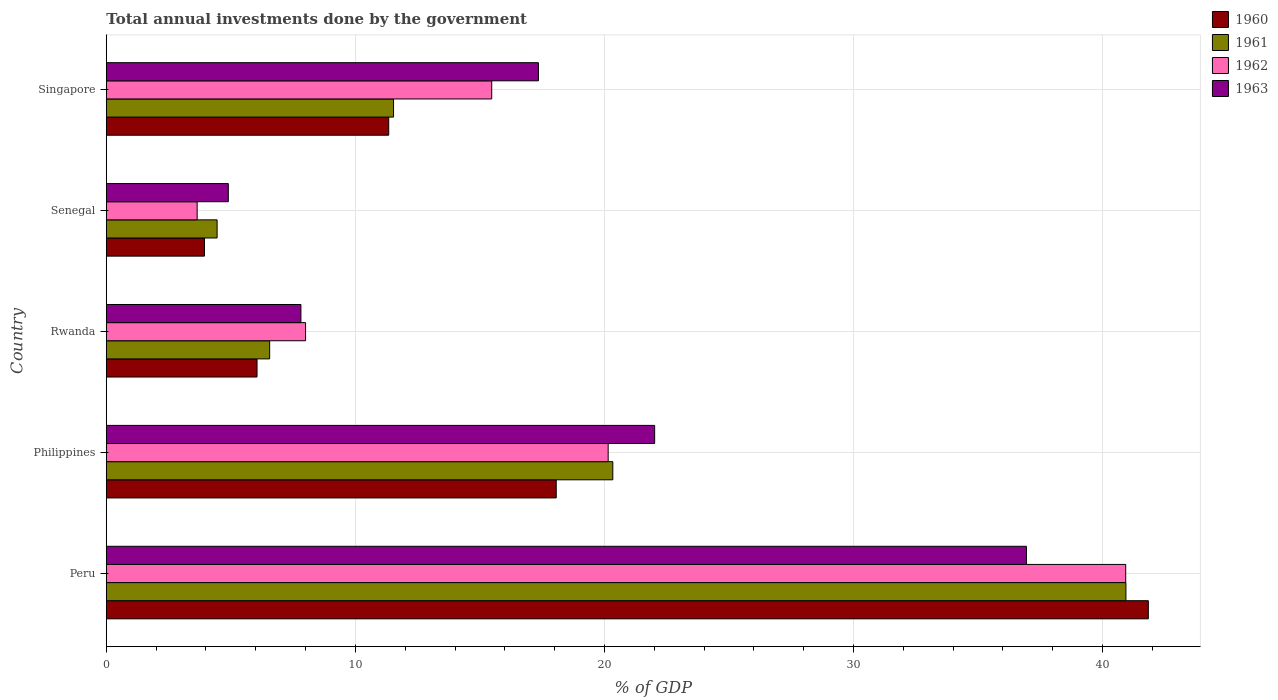How many groups of bars are there?
Your answer should be very brief. 5. Are the number of bars per tick equal to the number of legend labels?
Ensure brevity in your answer.  Yes. How many bars are there on the 1st tick from the bottom?
Keep it short and to the point. 4. What is the label of the 3rd group of bars from the top?
Provide a short and direct response. Rwanda. What is the total annual investments done by the government in 1963 in Rwanda?
Make the answer very short. 7.81. Across all countries, what is the maximum total annual investments done by the government in 1963?
Ensure brevity in your answer.  36.94. Across all countries, what is the minimum total annual investments done by the government in 1961?
Make the answer very short. 4.45. In which country was the total annual investments done by the government in 1960 maximum?
Offer a very short reply. Peru. In which country was the total annual investments done by the government in 1961 minimum?
Ensure brevity in your answer.  Senegal. What is the total total annual investments done by the government in 1962 in the graph?
Make the answer very short. 88.2. What is the difference between the total annual investments done by the government in 1961 in Senegal and that in Singapore?
Offer a very short reply. -7.08. What is the difference between the total annual investments done by the government in 1963 in Rwanda and the total annual investments done by the government in 1962 in Senegal?
Make the answer very short. 4.17. What is the average total annual investments done by the government in 1961 per country?
Make the answer very short. 16.76. What is the difference between the total annual investments done by the government in 1961 and total annual investments done by the government in 1960 in Philippines?
Offer a very short reply. 2.27. What is the ratio of the total annual investments done by the government in 1961 in Peru to that in Senegal?
Your response must be concise. 9.2. Is the total annual investments done by the government in 1961 in Peru less than that in Rwanda?
Offer a very short reply. No. Is the difference between the total annual investments done by the government in 1961 in Peru and Rwanda greater than the difference between the total annual investments done by the government in 1960 in Peru and Rwanda?
Give a very brief answer. No. What is the difference between the highest and the second highest total annual investments done by the government in 1962?
Offer a terse response. 20.78. What is the difference between the highest and the lowest total annual investments done by the government in 1960?
Give a very brief answer. 37.9. Is the sum of the total annual investments done by the government in 1960 in Rwanda and Senegal greater than the maximum total annual investments done by the government in 1962 across all countries?
Your answer should be very brief. No. Is it the case that in every country, the sum of the total annual investments done by the government in 1963 and total annual investments done by the government in 1961 is greater than the sum of total annual investments done by the government in 1962 and total annual investments done by the government in 1960?
Make the answer very short. No. What does the 3rd bar from the top in Philippines represents?
Your answer should be very brief. 1961. Is it the case that in every country, the sum of the total annual investments done by the government in 1962 and total annual investments done by the government in 1961 is greater than the total annual investments done by the government in 1960?
Provide a short and direct response. Yes. How many bars are there?
Provide a succinct answer. 20. What is the difference between two consecutive major ticks on the X-axis?
Offer a very short reply. 10. Does the graph contain any zero values?
Offer a very short reply. No. Does the graph contain grids?
Your answer should be very brief. Yes. How many legend labels are there?
Provide a short and direct response. 4. What is the title of the graph?
Offer a very short reply. Total annual investments done by the government. What is the label or title of the X-axis?
Provide a short and direct response. % of GDP. What is the label or title of the Y-axis?
Your response must be concise. Country. What is the % of GDP of 1960 in Peru?
Offer a terse response. 41.84. What is the % of GDP of 1961 in Peru?
Provide a short and direct response. 40.94. What is the % of GDP in 1962 in Peru?
Make the answer very short. 40.93. What is the % of GDP in 1963 in Peru?
Offer a terse response. 36.94. What is the % of GDP of 1960 in Philippines?
Provide a short and direct response. 18.06. What is the % of GDP of 1961 in Philippines?
Provide a short and direct response. 20.34. What is the % of GDP of 1962 in Philippines?
Ensure brevity in your answer.  20.15. What is the % of GDP in 1963 in Philippines?
Make the answer very short. 22.02. What is the % of GDP in 1960 in Rwanda?
Provide a short and direct response. 6.05. What is the % of GDP in 1961 in Rwanda?
Your answer should be very brief. 6.56. What is the % of GDP of 1962 in Rwanda?
Ensure brevity in your answer.  8. What is the % of GDP of 1963 in Rwanda?
Your response must be concise. 7.81. What is the % of GDP of 1960 in Senegal?
Keep it short and to the point. 3.94. What is the % of GDP in 1961 in Senegal?
Your answer should be very brief. 4.45. What is the % of GDP in 1962 in Senegal?
Make the answer very short. 3.65. What is the % of GDP in 1963 in Senegal?
Make the answer very short. 4.9. What is the % of GDP in 1960 in Singapore?
Make the answer very short. 11.34. What is the % of GDP of 1961 in Singapore?
Keep it short and to the point. 11.53. What is the % of GDP in 1962 in Singapore?
Your answer should be very brief. 15.47. What is the % of GDP in 1963 in Singapore?
Provide a succinct answer. 17.35. Across all countries, what is the maximum % of GDP in 1960?
Provide a short and direct response. 41.84. Across all countries, what is the maximum % of GDP of 1961?
Make the answer very short. 40.94. Across all countries, what is the maximum % of GDP in 1962?
Make the answer very short. 40.93. Across all countries, what is the maximum % of GDP in 1963?
Make the answer very short. 36.94. Across all countries, what is the minimum % of GDP in 1960?
Provide a short and direct response. 3.94. Across all countries, what is the minimum % of GDP of 1961?
Your answer should be very brief. 4.45. Across all countries, what is the minimum % of GDP of 1962?
Offer a terse response. 3.65. Across all countries, what is the minimum % of GDP of 1963?
Keep it short and to the point. 4.9. What is the total % of GDP in 1960 in the graph?
Offer a very short reply. 81.23. What is the total % of GDP of 1961 in the graph?
Keep it short and to the point. 83.81. What is the total % of GDP of 1962 in the graph?
Your response must be concise. 88.2. What is the total % of GDP of 1963 in the graph?
Provide a succinct answer. 89.02. What is the difference between the % of GDP in 1960 in Peru and that in Philippines?
Your answer should be compact. 23.77. What is the difference between the % of GDP of 1961 in Peru and that in Philippines?
Make the answer very short. 20.6. What is the difference between the % of GDP of 1962 in Peru and that in Philippines?
Offer a terse response. 20.78. What is the difference between the % of GDP of 1963 in Peru and that in Philippines?
Provide a succinct answer. 14.93. What is the difference between the % of GDP of 1960 in Peru and that in Rwanda?
Provide a short and direct response. 35.79. What is the difference between the % of GDP in 1961 in Peru and that in Rwanda?
Offer a very short reply. 34.38. What is the difference between the % of GDP of 1962 in Peru and that in Rwanda?
Make the answer very short. 32.93. What is the difference between the % of GDP of 1963 in Peru and that in Rwanda?
Keep it short and to the point. 29.13. What is the difference between the % of GDP in 1960 in Peru and that in Senegal?
Your answer should be very brief. 37.9. What is the difference between the % of GDP of 1961 in Peru and that in Senegal?
Offer a terse response. 36.49. What is the difference between the % of GDP of 1962 in Peru and that in Senegal?
Offer a terse response. 37.28. What is the difference between the % of GDP of 1963 in Peru and that in Senegal?
Give a very brief answer. 32.04. What is the difference between the % of GDP in 1960 in Peru and that in Singapore?
Offer a very short reply. 30.5. What is the difference between the % of GDP in 1961 in Peru and that in Singapore?
Make the answer very short. 29.41. What is the difference between the % of GDP of 1962 in Peru and that in Singapore?
Your response must be concise. 25.45. What is the difference between the % of GDP of 1963 in Peru and that in Singapore?
Offer a very short reply. 19.59. What is the difference between the % of GDP of 1960 in Philippines and that in Rwanda?
Offer a terse response. 12.01. What is the difference between the % of GDP of 1961 in Philippines and that in Rwanda?
Ensure brevity in your answer.  13.78. What is the difference between the % of GDP in 1962 in Philippines and that in Rwanda?
Your answer should be very brief. 12.15. What is the difference between the % of GDP in 1963 in Philippines and that in Rwanda?
Your answer should be compact. 14.2. What is the difference between the % of GDP of 1960 in Philippines and that in Senegal?
Ensure brevity in your answer.  14.12. What is the difference between the % of GDP of 1961 in Philippines and that in Senegal?
Your answer should be compact. 15.89. What is the difference between the % of GDP of 1962 in Philippines and that in Senegal?
Provide a succinct answer. 16.5. What is the difference between the % of GDP of 1963 in Philippines and that in Senegal?
Ensure brevity in your answer.  17.12. What is the difference between the % of GDP in 1960 in Philippines and that in Singapore?
Provide a succinct answer. 6.73. What is the difference between the % of GDP in 1961 in Philippines and that in Singapore?
Your answer should be compact. 8.8. What is the difference between the % of GDP in 1962 in Philippines and that in Singapore?
Your answer should be very brief. 4.68. What is the difference between the % of GDP of 1963 in Philippines and that in Singapore?
Provide a succinct answer. 4.67. What is the difference between the % of GDP in 1960 in Rwanda and that in Senegal?
Provide a succinct answer. 2.11. What is the difference between the % of GDP of 1961 in Rwanda and that in Senegal?
Provide a short and direct response. 2.11. What is the difference between the % of GDP of 1962 in Rwanda and that in Senegal?
Provide a succinct answer. 4.35. What is the difference between the % of GDP of 1963 in Rwanda and that in Senegal?
Give a very brief answer. 2.91. What is the difference between the % of GDP in 1960 in Rwanda and that in Singapore?
Provide a succinct answer. -5.29. What is the difference between the % of GDP of 1961 in Rwanda and that in Singapore?
Offer a very short reply. -4.97. What is the difference between the % of GDP of 1962 in Rwanda and that in Singapore?
Your answer should be compact. -7.47. What is the difference between the % of GDP of 1963 in Rwanda and that in Singapore?
Provide a short and direct response. -9.54. What is the difference between the % of GDP of 1960 in Senegal and that in Singapore?
Give a very brief answer. -7.4. What is the difference between the % of GDP of 1961 in Senegal and that in Singapore?
Ensure brevity in your answer.  -7.08. What is the difference between the % of GDP of 1962 in Senegal and that in Singapore?
Provide a short and direct response. -11.83. What is the difference between the % of GDP of 1963 in Senegal and that in Singapore?
Provide a succinct answer. -12.45. What is the difference between the % of GDP of 1960 in Peru and the % of GDP of 1961 in Philippines?
Offer a terse response. 21.5. What is the difference between the % of GDP of 1960 in Peru and the % of GDP of 1962 in Philippines?
Give a very brief answer. 21.69. What is the difference between the % of GDP of 1960 in Peru and the % of GDP of 1963 in Philippines?
Offer a very short reply. 19.82. What is the difference between the % of GDP of 1961 in Peru and the % of GDP of 1962 in Philippines?
Make the answer very short. 20.79. What is the difference between the % of GDP of 1961 in Peru and the % of GDP of 1963 in Philippines?
Offer a very short reply. 18.92. What is the difference between the % of GDP in 1962 in Peru and the % of GDP in 1963 in Philippines?
Provide a short and direct response. 18.91. What is the difference between the % of GDP in 1960 in Peru and the % of GDP in 1961 in Rwanda?
Provide a short and direct response. 35.28. What is the difference between the % of GDP of 1960 in Peru and the % of GDP of 1962 in Rwanda?
Provide a succinct answer. 33.84. What is the difference between the % of GDP of 1960 in Peru and the % of GDP of 1963 in Rwanda?
Offer a terse response. 34.02. What is the difference between the % of GDP of 1961 in Peru and the % of GDP of 1962 in Rwanda?
Give a very brief answer. 32.94. What is the difference between the % of GDP in 1961 in Peru and the % of GDP in 1963 in Rwanda?
Provide a succinct answer. 33.12. What is the difference between the % of GDP of 1962 in Peru and the % of GDP of 1963 in Rwanda?
Provide a short and direct response. 33.12. What is the difference between the % of GDP in 1960 in Peru and the % of GDP in 1961 in Senegal?
Provide a succinct answer. 37.39. What is the difference between the % of GDP in 1960 in Peru and the % of GDP in 1962 in Senegal?
Offer a very short reply. 38.19. What is the difference between the % of GDP in 1960 in Peru and the % of GDP in 1963 in Senegal?
Make the answer very short. 36.94. What is the difference between the % of GDP of 1961 in Peru and the % of GDP of 1962 in Senegal?
Provide a succinct answer. 37.29. What is the difference between the % of GDP in 1961 in Peru and the % of GDP in 1963 in Senegal?
Give a very brief answer. 36.04. What is the difference between the % of GDP in 1962 in Peru and the % of GDP in 1963 in Senegal?
Provide a short and direct response. 36.03. What is the difference between the % of GDP in 1960 in Peru and the % of GDP in 1961 in Singapore?
Provide a short and direct response. 30.3. What is the difference between the % of GDP in 1960 in Peru and the % of GDP in 1962 in Singapore?
Offer a very short reply. 26.36. What is the difference between the % of GDP in 1960 in Peru and the % of GDP in 1963 in Singapore?
Provide a succinct answer. 24.49. What is the difference between the % of GDP in 1961 in Peru and the % of GDP in 1962 in Singapore?
Provide a succinct answer. 25.46. What is the difference between the % of GDP of 1961 in Peru and the % of GDP of 1963 in Singapore?
Your answer should be very brief. 23.59. What is the difference between the % of GDP of 1962 in Peru and the % of GDP of 1963 in Singapore?
Offer a very short reply. 23.58. What is the difference between the % of GDP in 1960 in Philippines and the % of GDP in 1961 in Rwanda?
Your answer should be compact. 11.51. What is the difference between the % of GDP of 1960 in Philippines and the % of GDP of 1962 in Rwanda?
Your answer should be very brief. 10.06. What is the difference between the % of GDP of 1960 in Philippines and the % of GDP of 1963 in Rwanda?
Make the answer very short. 10.25. What is the difference between the % of GDP of 1961 in Philippines and the % of GDP of 1962 in Rwanda?
Provide a succinct answer. 12.34. What is the difference between the % of GDP of 1961 in Philippines and the % of GDP of 1963 in Rwanda?
Your answer should be compact. 12.52. What is the difference between the % of GDP in 1962 in Philippines and the % of GDP in 1963 in Rwanda?
Make the answer very short. 12.34. What is the difference between the % of GDP in 1960 in Philippines and the % of GDP in 1961 in Senegal?
Offer a very short reply. 13.62. What is the difference between the % of GDP of 1960 in Philippines and the % of GDP of 1962 in Senegal?
Offer a terse response. 14.42. What is the difference between the % of GDP in 1960 in Philippines and the % of GDP in 1963 in Senegal?
Ensure brevity in your answer.  13.17. What is the difference between the % of GDP of 1961 in Philippines and the % of GDP of 1962 in Senegal?
Your answer should be compact. 16.69. What is the difference between the % of GDP of 1961 in Philippines and the % of GDP of 1963 in Senegal?
Give a very brief answer. 15.44. What is the difference between the % of GDP in 1962 in Philippines and the % of GDP in 1963 in Senegal?
Your response must be concise. 15.25. What is the difference between the % of GDP in 1960 in Philippines and the % of GDP in 1961 in Singapore?
Keep it short and to the point. 6.53. What is the difference between the % of GDP of 1960 in Philippines and the % of GDP of 1962 in Singapore?
Offer a very short reply. 2.59. What is the difference between the % of GDP in 1960 in Philippines and the % of GDP in 1963 in Singapore?
Offer a terse response. 0.72. What is the difference between the % of GDP of 1961 in Philippines and the % of GDP of 1962 in Singapore?
Your answer should be compact. 4.86. What is the difference between the % of GDP of 1961 in Philippines and the % of GDP of 1963 in Singapore?
Your response must be concise. 2.99. What is the difference between the % of GDP of 1962 in Philippines and the % of GDP of 1963 in Singapore?
Give a very brief answer. 2.8. What is the difference between the % of GDP in 1960 in Rwanda and the % of GDP in 1961 in Senegal?
Your answer should be compact. 1.6. What is the difference between the % of GDP in 1960 in Rwanda and the % of GDP in 1962 in Senegal?
Offer a terse response. 2.4. What is the difference between the % of GDP of 1960 in Rwanda and the % of GDP of 1963 in Senegal?
Make the answer very short. 1.15. What is the difference between the % of GDP in 1961 in Rwanda and the % of GDP in 1962 in Senegal?
Provide a succinct answer. 2.91. What is the difference between the % of GDP of 1961 in Rwanda and the % of GDP of 1963 in Senegal?
Provide a short and direct response. 1.66. What is the difference between the % of GDP of 1962 in Rwanda and the % of GDP of 1963 in Senegal?
Offer a very short reply. 3.1. What is the difference between the % of GDP in 1960 in Rwanda and the % of GDP in 1961 in Singapore?
Offer a very short reply. -5.48. What is the difference between the % of GDP of 1960 in Rwanda and the % of GDP of 1962 in Singapore?
Provide a succinct answer. -9.42. What is the difference between the % of GDP in 1960 in Rwanda and the % of GDP in 1963 in Singapore?
Make the answer very short. -11.3. What is the difference between the % of GDP of 1961 in Rwanda and the % of GDP of 1962 in Singapore?
Provide a short and direct response. -8.92. What is the difference between the % of GDP of 1961 in Rwanda and the % of GDP of 1963 in Singapore?
Offer a very short reply. -10.79. What is the difference between the % of GDP in 1962 in Rwanda and the % of GDP in 1963 in Singapore?
Ensure brevity in your answer.  -9.35. What is the difference between the % of GDP of 1960 in Senegal and the % of GDP of 1961 in Singapore?
Offer a very short reply. -7.59. What is the difference between the % of GDP of 1960 in Senegal and the % of GDP of 1962 in Singapore?
Provide a short and direct response. -11.53. What is the difference between the % of GDP of 1960 in Senegal and the % of GDP of 1963 in Singapore?
Offer a terse response. -13.41. What is the difference between the % of GDP in 1961 in Senegal and the % of GDP in 1962 in Singapore?
Provide a short and direct response. -11.03. What is the difference between the % of GDP in 1961 in Senegal and the % of GDP in 1963 in Singapore?
Provide a succinct answer. -12.9. What is the difference between the % of GDP of 1962 in Senegal and the % of GDP of 1963 in Singapore?
Your answer should be very brief. -13.7. What is the average % of GDP of 1960 per country?
Keep it short and to the point. 16.25. What is the average % of GDP of 1961 per country?
Ensure brevity in your answer.  16.76. What is the average % of GDP of 1962 per country?
Ensure brevity in your answer.  17.64. What is the average % of GDP of 1963 per country?
Keep it short and to the point. 17.8. What is the difference between the % of GDP in 1960 and % of GDP in 1961 in Peru?
Your answer should be very brief. 0.9. What is the difference between the % of GDP in 1960 and % of GDP in 1962 in Peru?
Your answer should be very brief. 0.91. What is the difference between the % of GDP in 1960 and % of GDP in 1963 in Peru?
Your answer should be very brief. 4.89. What is the difference between the % of GDP of 1961 and % of GDP of 1962 in Peru?
Provide a short and direct response. 0.01. What is the difference between the % of GDP of 1961 and % of GDP of 1963 in Peru?
Offer a very short reply. 3.99. What is the difference between the % of GDP of 1962 and % of GDP of 1963 in Peru?
Your answer should be compact. 3.99. What is the difference between the % of GDP of 1960 and % of GDP of 1961 in Philippines?
Offer a terse response. -2.27. What is the difference between the % of GDP of 1960 and % of GDP of 1962 in Philippines?
Make the answer very short. -2.09. What is the difference between the % of GDP of 1960 and % of GDP of 1963 in Philippines?
Make the answer very short. -3.95. What is the difference between the % of GDP of 1961 and % of GDP of 1962 in Philippines?
Give a very brief answer. 0.19. What is the difference between the % of GDP of 1961 and % of GDP of 1963 in Philippines?
Make the answer very short. -1.68. What is the difference between the % of GDP of 1962 and % of GDP of 1963 in Philippines?
Offer a terse response. -1.87. What is the difference between the % of GDP of 1960 and % of GDP of 1961 in Rwanda?
Provide a short and direct response. -0.51. What is the difference between the % of GDP in 1960 and % of GDP in 1962 in Rwanda?
Give a very brief answer. -1.95. What is the difference between the % of GDP of 1960 and % of GDP of 1963 in Rwanda?
Keep it short and to the point. -1.76. What is the difference between the % of GDP in 1961 and % of GDP in 1962 in Rwanda?
Your response must be concise. -1.44. What is the difference between the % of GDP of 1961 and % of GDP of 1963 in Rwanda?
Provide a succinct answer. -1.26. What is the difference between the % of GDP in 1962 and % of GDP in 1963 in Rwanda?
Offer a very short reply. 0.19. What is the difference between the % of GDP in 1960 and % of GDP in 1961 in Senegal?
Your answer should be compact. -0.51. What is the difference between the % of GDP of 1960 and % of GDP of 1962 in Senegal?
Your answer should be compact. 0.29. What is the difference between the % of GDP of 1960 and % of GDP of 1963 in Senegal?
Give a very brief answer. -0.96. What is the difference between the % of GDP of 1961 and % of GDP of 1962 in Senegal?
Your answer should be compact. 0.8. What is the difference between the % of GDP of 1961 and % of GDP of 1963 in Senegal?
Make the answer very short. -0.45. What is the difference between the % of GDP of 1962 and % of GDP of 1963 in Senegal?
Your answer should be very brief. -1.25. What is the difference between the % of GDP in 1960 and % of GDP in 1961 in Singapore?
Your answer should be very brief. -0.19. What is the difference between the % of GDP in 1960 and % of GDP in 1962 in Singapore?
Your answer should be compact. -4.14. What is the difference between the % of GDP of 1960 and % of GDP of 1963 in Singapore?
Make the answer very short. -6.01. What is the difference between the % of GDP in 1961 and % of GDP in 1962 in Singapore?
Your response must be concise. -3.94. What is the difference between the % of GDP of 1961 and % of GDP of 1963 in Singapore?
Offer a very short reply. -5.82. What is the difference between the % of GDP in 1962 and % of GDP in 1963 in Singapore?
Ensure brevity in your answer.  -1.87. What is the ratio of the % of GDP in 1960 in Peru to that in Philippines?
Your response must be concise. 2.32. What is the ratio of the % of GDP in 1961 in Peru to that in Philippines?
Your answer should be very brief. 2.01. What is the ratio of the % of GDP in 1962 in Peru to that in Philippines?
Provide a short and direct response. 2.03. What is the ratio of the % of GDP of 1963 in Peru to that in Philippines?
Ensure brevity in your answer.  1.68. What is the ratio of the % of GDP in 1960 in Peru to that in Rwanda?
Offer a terse response. 6.91. What is the ratio of the % of GDP in 1961 in Peru to that in Rwanda?
Keep it short and to the point. 6.24. What is the ratio of the % of GDP of 1962 in Peru to that in Rwanda?
Offer a terse response. 5.12. What is the ratio of the % of GDP of 1963 in Peru to that in Rwanda?
Your answer should be very brief. 4.73. What is the ratio of the % of GDP in 1960 in Peru to that in Senegal?
Ensure brevity in your answer.  10.62. What is the ratio of the % of GDP in 1961 in Peru to that in Senegal?
Make the answer very short. 9.2. What is the ratio of the % of GDP in 1962 in Peru to that in Senegal?
Offer a very short reply. 11.22. What is the ratio of the % of GDP in 1963 in Peru to that in Senegal?
Keep it short and to the point. 7.54. What is the ratio of the % of GDP of 1960 in Peru to that in Singapore?
Ensure brevity in your answer.  3.69. What is the ratio of the % of GDP of 1961 in Peru to that in Singapore?
Provide a succinct answer. 3.55. What is the ratio of the % of GDP in 1962 in Peru to that in Singapore?
Give a very brief answer. 2.65. What is the ratio of the % of GDP of 1963 in Peru to that in Singapore?
Keep it short and to the point. 2.13. What is the ratio of the % of GDP in 1960 in Philippines to that in Rwanda?
Offer a very short reply. 2.99. What is the ratio of the % of GDP of 1961 in Philippines to that in Rwanda?
Your answer should be compact. 3.1. What is the ratio of the % of GDP in 1962 in Philippines to that in Rwanda?
Your answer should be compact. 2.52. What is the ratio of the % of GDP of 1963 in Philippines to that in Rwanda?
Offer a very short reply. 2.82. What is the ratio of the % of GDP of 1960 in Philippines to that in Senegal?
Give a very brief answer. 4.58. What is the ratio of the % of GDP of 1961 in Philippines to that in Senegal?
Your response must be concise. 4.57. What is the ratio of the % of GDP of 1962 in Philippines to that in Senegal?
Offer a terse response. 5.53. What is the ratio of the % of GDP of 1963 in Philippines to that in Senegal?
Your answer should be very brief. 4.49. What is the ratio of the % of GDP in 1960 in Philippines to that in Singapore?
Keep it short and to the point. 1.59. What is the ratio of the % of GDP in 1961 in Philippines to that in Singapore?
Give a very brief answer. 1.76. What is the ratio of the % of GDP of 1962 in Philippines to that in Singapore?
Provide a succinct answer. 1.3. What is the ratio of the % of GDP in 1963 in Philippines to that in Singapore?
Offer a terse response. 1.27. What is the ratio of the % of GDP of 1960 in Rwanda to that in Senegal?
Give a very brief answer. 1.54. What is the ratio of the % of GDP in 1961 in Rwanda to that in Senegal?
Make the answer very short. 1.47. What is the ratio of the % of GDP of 1962 in Rwanda to that in Senegal?
Make the answer very short. 2.19. What is the ratio of the % of GDP of 1963 in Rwanda to that in Senegal?
Provide a succinct answer. 1.59. What is the ratio of the % of GDP in 1960 in Rwanda to that in Singapore?
Ensure brevity in your answer.  0.53. What is the ratio of the % of GDP in 1961 in Rwanda to that in Singapore?
Make the answer very short. 0.57. What is the ratio of the % of GDP of 1962 in Rwanda to that in Singapore?
Offer a terse response. 0.52. What is the ratio of the % of GDP in 1963 in Rwanda to that in Singapore?
Keep it short and to the point. 0.45. What is the ratio of the % of GDP of 1960 in Senegal to that in Singapore?
Offer a very short reply. 0.35. What is the ratio of the % of GDP in 1961 in Senegal to that in Singapore?
Provide a short and direct response. 0.39. What is the ratio of the % of GDP of 1962 in Senegal to that in Singapore?
Your answer should be compact. 0.24. What is the ratio of the % of GDP in 1963 in Senegal to that in Singapore?
Offer a very short reply. 0.28. What is the difference between the highest and the second highest % of GDP of 1960?
Your response must be concise. 23.77. What is the difference between the highest and the second highest % of GDP in 1961?
Provide a short and direct response. 20.6. What is the difference between the highest and the second highest % of GDP in 1962?
Keep it short and to the point. 20.78. What is the difference between the highest and the second highest % of GDP of 1963?
Provide a succinct answer. 14.93. What is the difference between the highest and the lowest % of GDP of 1960?
Offer a very short reply. 37.9. What is the difference between the highest and the lowest % of GDP of 1961?
Offer a terse response. 36.49. What is the difference between the highest and the lowest % of GDP in 1962?
Offer a terse response. 37.28. What is the difference between the highest and the lowest % of GDP of 1963?
Keep it short and to the point. 32.04. 